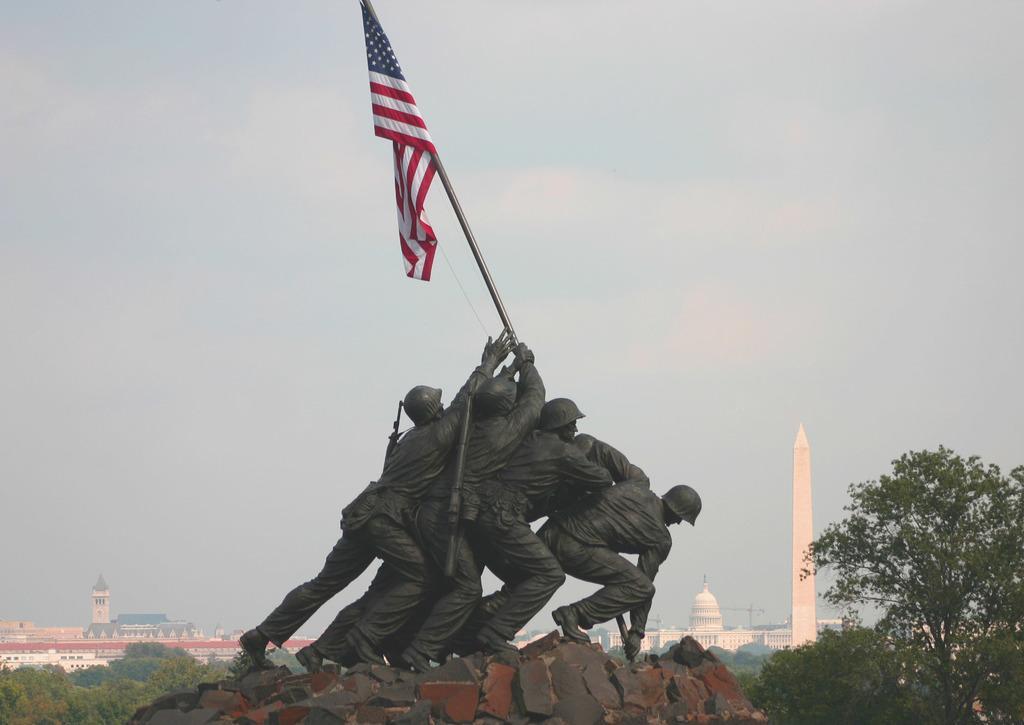How would you summarize this image in a sentence or two? In the center of the image there are depictions of persons. There is a flag. In the background of the image there are buildings. There are trees. At the bottom of the image there are stones. 